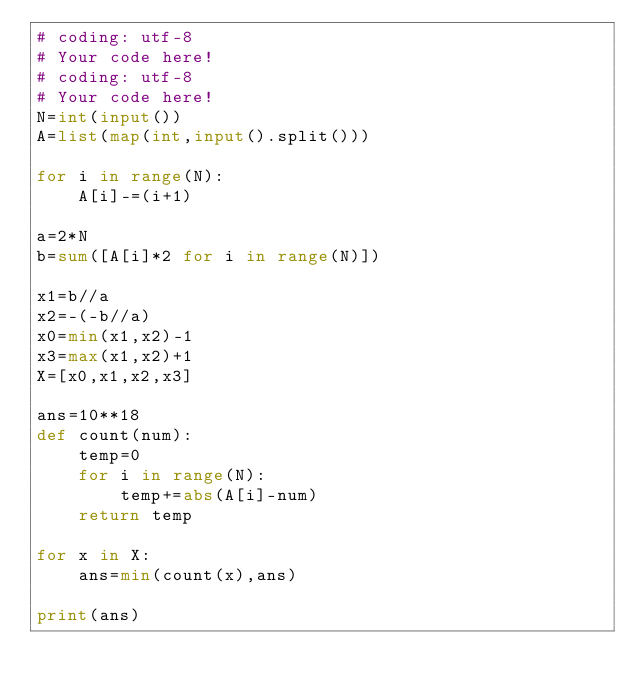<code> <loc_0><loc_0><loc_500><loc_500><_Python_># coding: utf-8
# Your code here!
# coding: utf-8
# Your code here!
N=int(input())
A=list(map(int,input().split()))

for i in range(N):
    A[i]-=(i+1)

a=2*N
b=sum([A[i]*2 for i in range(N)])

x1=b//a
x2=-(-b//a)
x0=min(x1,x2)-1
x3=max(x1,x2)+1
X=[x0,x1,x2,x3]

ans=10**18
def count(num):
    temp=0
    for i in range(N):
        temp+=abs(A[i]-num)
    return temp

for x in X:
    ans=min(count(x),ans)

print(ans)

</code> 